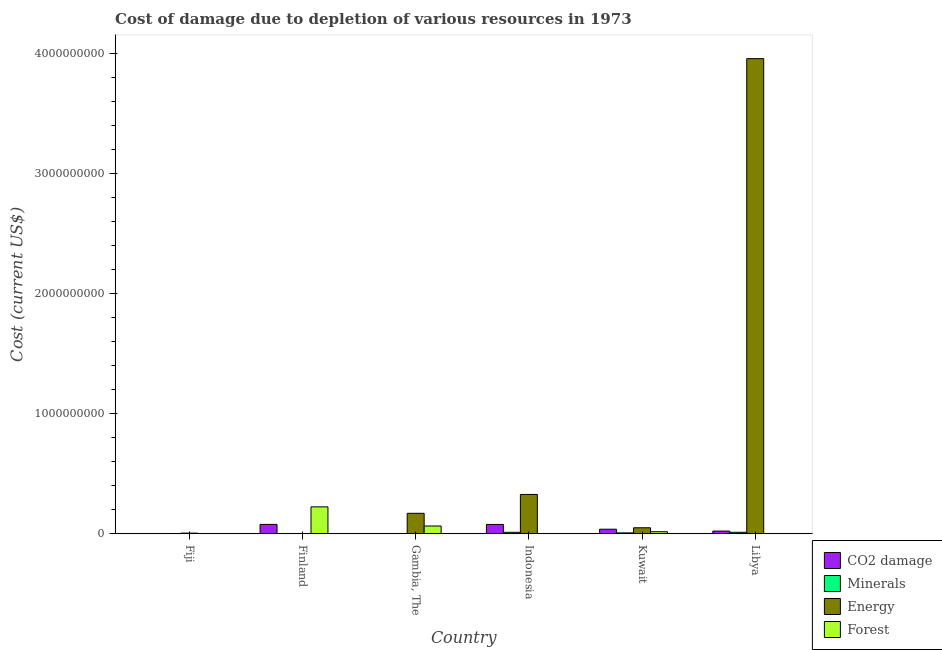Are the number of bars on each tick of the X-axis equal?
Keep it short and to the point. Yes. How many bars are there on the 1st tick from the left?
Your answer should be very brief. 4. How many bars are there on the 5th tick from the right?
Keep it short and to the point. 4. What is the label of the 6th group of bars from the left?
Make the answer very short. Libya. What is the cost of damage due to depletion of coal in Finland?
Ensure brevity in your answer.  7.89e+07. Across all countries, what is the maximum cost of damage due to depletion of coal?
Offer a terse response. 7.89e+07. Across all countries, what is the minimum cost of damage due to depletion of forests?
Make the answer very short. 4.73e+05. In which country was the cost of damage due to depletion of coal maximum?
Make the answer very short. Finland. In which country was the cost of damage due to depletion of forests minimum?
Your response must be concise. Libya. What is the total cost of damage due to depletion of energy in the graph?
Offer a very short reply. 4.52e+09. What is the difference between the cost of damage due to depletion of energy in Gambia, The and that in Libya?
Provide a short and direct response. -3.79e+09. What is the difference between the cost of damage due to depletion of minerals in Gambia, The and the cost of damage due to depletion of forests in Kuwait?
Your response must be concise. -1.75e+07. What is the average cost of damage due to depletion of energy per country?
Your response must be concise. 7.53e+08. What is the difference between the cost of damage due to depletion of forests and cost of damage due to depletion of minerals in Fiji?
Give a very brief answer. -1.21e+06. In how many countries, is the cost of damage due to depletion of energy greater than 1800000000 US$?
Give a very brief answer. 1. What is the ratio of the cost of damage due to depletion of minerals in Finland to that in Libya?
Your answer should be very brief. 0. Is the difference between the cost of damage due to depletion of forests in Fiji and Indonesia greater than the difference between the cost of damage due to depletion of minerals in Fiji and Indonesia?
Keep it short and to the point. Yes. What is the difference between the highest and the second highest cost of damage due to depletion of energy?
Offer a very short reply. 3.63e+09. What is the difference between the highest and the lowest cost of damage due to depletion of minerals?
Your answer should be compact. 1.30e+07. In how many countries, is the cost of damage due to depletion of energy greater than the average cost of damage due to depletion of energy taken over all countries?
Your response must be concise. 1. Is it the case that in every country, the sum of the cost of damage due to depletion of forests and cost of damage due to depletion of coal is greater than the sum of cost of damage due to depletion of energy and cost of damage due to depletion of minerals?
Ensure brevity in your answer.  No. What does the 4th bar from the left in Finland represents?
Make the answer very short. Forest. What does the 2nd bar from the right in Finland represents?
Keep it short and to the point. Energy. Are all the bars in the graph horizontal?
Your answer should be compact. No. How many countries are there in the graph?
Make the answer very short. 6. What is the difference between two consecutive major ticks on the Y-axis?
Offer a very short reply. 1.00e+09. Are the values on the major ticks of Y-axis written in scientific E-notation?
Offer a very short reply. No. Does the graph contain any zero values?
Your answer should be compact. No. Where does the legend appear in the graph?
Provide a short and direct response. Bottom right. What is the title of the graph?
Offer a very short reply. Cost of damage due to depletion of various resources in 1973 . What is the label or title of the Y-axis?
Make the answer very short. Cost (current US$). What is the Cost (current US$) in CO2 damage in Fiji?
Ensure brevity in your answer.  1.01e+06. What is the Cost (current US$) of Minerals in Fiji?
Offer a terse response. 3.11e+06. What is the Cost (current US$) of Energy in Fiji?
Your response must be concise. 6.23e+06. What is the Cost (current US$) of Forest in Fiji?
Make the answer very short. 1.90e+06. What is the Cost (current US$) of CO2 damage in Finland?
Your response must be concise. 7.89e+07. What is the Cost (current US$) in Minerals in Finland?
Make the answer very short. 5.65e+04. What is the Cost (current US$) in Energy in Finland?
Your answer should be compact. 1.24e+06. What is the Cost (current US$) in Forest in Finland?
Make the answer very short. 2.25e+08. What is the Cost (current US$) in CO2 damage in Gambia, The?
Give a very brief answer. 9.96e+04. What is the Cost (current US$) in Minerals in Gambia, The?
Provide a short and direct response. 1.93e+05. What is the Cost (current US$) of Energy in Gambia, The?
Give a very brief answer. 1.71e+08. What is the Cost (current US$) of Forest in Gambia, The?
Your answer should be compact. 6.54e+07. What is the Cost (current US$) in CO2 damage in Indonesia?
Your answer should be compact. 7.85e+07. What is the Cost (current US$) of Minerals in Indonesia?
Your answer should be compact. 1.30e+07. What is the Cost (current US$) of Energy in Indonesia?
Your answer should be very brief. 3.29e+08. What is the Cost (current US$) in Forest in Indonesia?
Offer a terse response. 9.01e+05. What is the Cost (current US$) in CO2 damage in Kuwait?
Provide a short and direct response. 3.87e+07. What is the Cost (current US$) of Minerals in Kuwait?
Provide a short and direct response. 8.13e+06. What is the Cost (current US$) of Energy in Kuwait?
Your answer should be very brief. 5.08e+07. What is the Cost (current US$) of Forest in Kuwait?
Offer a terse response. 1.77e+07. What is the Cost (current US$) in CO2 damage in Libya?
Your response must be concise. 2.33e+07. What is the Cost (current US$) of Minerals in Libya?
Keep it short and to the point. 1.31e+07. What is the Cost (current US$) in Energy in Libya?
Offer a very short reply. 3.96e+09. What is the Cost (current US$) in Forest in Libya?
Provide a short and direct response. 4.73e+05. Across all countries, what is the maximum Cost (current US$) in CO2 damage?
Make the answer very short. 7.89e+07. Across all countries, what is the maximum Cost (current US$) of Minerals?
Your response must be concise. 1.31e+07. Across all countries, what is the maximum Cost (current US$) in Energy?
Make the answer very short. 3.96e+09. Across all countries, what is the maximum Cost (current US$) in Forest?
Ensure brevity in your answer.  2.25e+08. Across all countries, what is the minimum Cost (current US$) of CO2 damage?
Give a very brief answer. 9.96e+04. Across all countries, what is the minimum Cost (current US$) of Minerals?
Keep it short and to the point. 5.65e+04. Across all countries, what is the minimum Cost (current US$) in Energy?
Make the answer very short. 1.24e+06. Across all countries, what is the minimum Cost (current US$) in Forest?
Your response must be concise. 4.73e+05. What is the total Cost (current US$) in CO2 damage in the graph?
Keep it short and to the point. 2.21e+08. What is the total Cost (current US$) in Minerals in the graph?
Ensure brevity in your answer.  3.76e+07. What is the total Cost (current US$) in Energy in the graph?
Provide a short and direct response. 4.52e+09. What is the total Cost (current US$) in Forest in the graph?
Your answer should be compact. 3.12e+08. What is the difference between the Cost (current US$) of CO2 damage in Fiji and that in Finland?
Make the answer very short. -7.79e+07. What is the difference between the Cost (current US$) of Minerals in Fiji and that in Finland?
Ensure brevity in your answer.  3.05e+06. What is the difference between the Cost (current US$) of Energy in Fiji and that in Finland?
Make the answer very short. 4.99e+06. What is the difference between the Cost (current US$) of Forest in Fiji and that in Finland?
Provide a succinct answer. -2.23e+08. What is the difference between the Cost (current US$) in CO2 damage in Fiji and that in Gambia, The?
Your answer should be very brief. 9.08e+05. What is the difference between the Cost (current US$) in Minerals in Fiji and that in Gambia, The?
Keep it short and to the point. 2.92e+06. What is the difference between the Cost (current US$) in Energy in Fiji and that in Gambia, The?
Give a very brief answer. -1.65e+08. What is the difference between the Cost (current US$) in Forest in Fiji and that in Gambia, The?
Offer a very short reply. -6.35e+07. What is the difference between the Cost (current US$) of CO2 damage in Fiji and that in Indonesia?
Ensure brevity in your answer.  -7.75e+07. What is the difference between the Cost (current US$) of Minerals in Fiji and that in Indonesia?
Provide a succinct answer. -9.91e+06. What is the difference between the Cost (current US$) of Energy in Fiji and that in Indonesia?
Your response must be concise. -3.22e+08. What is the difference between the Cost (current US$) of Forest in Fiji and that in Indonesia?
Keep it short and to the point. 1.00e+06. What is the difference between the Cost (current US$) in CO2 damage in Fiji and that in Kuwait?
Your answer should be very brief. -3.77e+07. What is the difference between the Cost (current US$) in Minerals in Fiji and that in Kuwait?
Provide a short and direct response. -5.02e+06. What is the difference between the Cost (current US$) of Energy in Fiji and that in Kuwait?
Ensure brevity in your answer.  -4.46e+07. What is the difference between the Cost (current US$) of Forest in Fiji and that in Kuwait?
Your response must be concise. -1.58e+07. What is the difference between the Cost (current US$) in CO2 damage in Fiji and that in Libya?
Your answer should be compact. -2.23e+07. What is the difference between the Cost (current US$) in Minerals in Fiji and that in Libya?
Offer a terse response. -9.97e+06. What is the difference between the Cost (current US$) in Energy in Fiji and that in Libya?
Your answer should be very brief. -3.96e+09. What is the difference between the Cost (current US$) in Forest in Fiji and that in Libya?
Your answer should be compact. 1.43e+06. What is the difference between the Cost (current US$) of CO2 damage in Finland and that in Gambia, The?
Give a very brief answer. 7.88e+07. What is the difference between the Cost (current US$) in Minerals in Finland and that in Gambia, The?
Your answer should be very brief. -1.36e+05. What is the difference between the Cost (current US$) of Energy in Finland and that in Gambia, The?
Ensure brevity in your answer.  -1.70e+08. What is the difference between the Cost (current US$) in Forest in Finland and that in Gambia, The?
Provide a succinct answer. 1.60e+08. What is the difference between the Cost (current US$) of CO2 damage in Finland and that in Indonesia?
Offer a terse response. 4.04e+05. What is the difference between the Cost (current US$) of Minerals in Finland and that in Indonesia?
Your response must be concise. -1.30e+07. What is the difference between the Cost (current US$) of Energy in Finland and that in Indonesia?
Give a very brief answer. -3.27e+08. What is the difference between the Cost (current US$) of Forest in Finland and that in Indonesia?
Your answer should be compact. 2.24e+08. What is the difference between the Cost (current US$) of CO2 damage in Finland and that in Kuwait?
Ensure brevity in your answer.  4.02e+07. What is the difference between the Cost (current US$) in Minerals in Finland and that in Kuwait?
Your answer should be compact. -8.07e+06. What is the difference between the Cost (current US$) in Energy in Finland and that in Kuwait?
Give a very brief answer. -4.96e+07. What is the difference between the Cost (current US$) of Forest in Finland and that in Kuwait?
Make the answer very short. 2.07e+08. What is the difference between the Cost (current US$) of CO2 damage in Finland and that in Libya?
Give a very brief answer. 5.56e+07. What is the difference between the Cost (current US$) in Minerals in Finland and that in Libya?
Give a very brief answer. -1.30e+07. What is the difference between the Cost (current US$) in Energy in Finland and that in Libya?
Give a very brief answer. -3.96e+09. What is the difference between the Cost (current US$) in Forest in Finland and that in Libya?
Your response must be concise. 2.25e+08. What is the difference between the Cost (current US$) in CO2 damage in Gambia, The and that in Indonesia?
Your answer should be compact. -7.84e+07. What is the difference between the Cost (current US$) of Minerals in Gambia, The and that in Indonesia?
Provide a short and direct response. -1.28e+07. What is the difference between the Cost (current US$) in Energy in Gambia, The and that in Indonesia?
Your answer should be very brief. -1.57e+08. What is the difference between the Cost (current US$) in Forest in Gambia, The and that in Indonesia?
Keep it short and to the point. 6.45e+07. What is the difference between the Cost (current US$) in CO2 damage in Gambia, The and that in Kuwait?
Provide a succinct answer. -3.86e+07. What is the difference between the Cost (current US$) in Minerals in Gambia, The and that in Kuwait?
Your answer should be very brief. -7.94e+06. What is the difference between the Cost (current US$) in Energy in Gambia, The and that in Kuwait?
Offer a terse response. 1.21e+08. What is the difference between the Cost (current US$) of Forest in Gambia, The and that in Kuwait?
Keep it short and to the point. 4.77e+07. What is the difference between the Cost (current US$) of CO2 damage in Gambia, The and that in Libya?
Provide a short and direct response. -2.32e+07. What is the difference between the Cost (current US$) in Minerals in Gambia, The and that in Libya?
Your answer should be compact. -1.29e+07. What is the difference between the Cost (current US$) of Energy in Gambia, The and that in Libya?
Give a very brief answer. -3.79e+09. What is the difference between the Cost (current US$) in Forest in Gambia, The and that in Libya?
Keep it short and to the point. 6.50e+07. What is the difference between the Cost (current US$) of CO2 damage in Indonesia and that in Kuwait?
Your answer should be very brief. 3.98e+07. What is the difference between the Cost (current US$) in Minerals in Indonesia and that in Kuwait?
Offer a very short reply. 4.89e+06. What is the difference between the Cost (current US$) of Energy in Indonesia and that in Kuwait?
Your answer should be compact. 2.78e+08. What is the difference between the Cost (current US$) in Forest in Indonesia and that in Kuwait?
Your answer should be very brief. -1.68e+07. What is the difference between the Cost (current US$) of CO2 damage in Indonesia and that in Libya?
Keep it short and to the point. 5.52e+07. What is the difference between the Cost (current US$) of Minerals in Indonesia and that in Libya?
Your answer should be compact. -6.05e+04. What is the difference between the Cost (current US$) of Energy in Indonesia and that in Libya?
Keep it short and to the point. -3.63e+09. What is the difference between the Cost (current US$) of Forest in Indonesia and that in Libya?
Offer a terse response. 4.28e+05. What is the difference between the Cost (current US$) in CO2 damage in Kuwait and that in Libya?
Keep it short and to the point. 1.54e+07. What is the difference between the Cost (current US$) in Minerals in Kuwait and that in Libya?
Your response must be concise. -4.95e+06. What is the difference between the Cost (current US$) in Energy in Kuwait and that in Libya?
Your response must be concise. -3.91e+09. What is the difference between the Cost (current US$) in Forest in Kuwait and that in Libya?
Your answer should be compact. 1.73e+07. What is the difference between the Cost (current US$) in CO2 damage in Fiji and the Cost (current US$) in Minerals in Finland?
Offer a very short reply. 9.51e+05. What is the difference between the Cost (current US$) in CO2 damage in Fiji and the Cost (current US$) in Energy in Finland?
Make the answer very short. -2.37e+05. What is the difference between the Cost (current US$) in CO2 damage in Fiji and the Cost (current US$) in Forest in Finland?
Provide a short and direct response. -2.24e+08. What is the difference between the Cost (current US$) of Minerals in Fiji and the Cost (current US$) of Energy in Finland?
Keep it short and to the point. 1.87e+06. What is the difference between the Cost (current US$) of Minerals in Fiji and the Cost (current US$) of Forest in Finland?
Keep it short and to the point. -2.22e+08. What is the difference between the Cost (current US$) in Energy in Fiji and the Cost (current US$) in Forest in Finland?
Ensure brevity in your answer.  -2.19e+08. What is the difference between the Cost (current US$) of CO2 damage in Fiji and the Cost (current US$) of Minerals in Gambia, The?
Give a very brief answer. 8.15e+05. What is the difference between the Cost (current US$) in CO2 damage in Fiji and the Cost (current US$) in Energy in Gambia, The?
Offer a terse response. -1.70e+08. What is the difference between the Cost (current US$) in CO2 damage in Fiji and the Cost (current US$) in Forest in Gambia, The?
Offer a very short reply. -6.44e+07. What is the difference between the Cost (current US$) of Minerals in Fiji and the Cost (current US$) of Energy in Gambia, The?
Your answer should be compact. -1.68e+08. What is the difference between the Cost (current US$) of Minerals in Fiji and the Cost (current US$) of Forest in Gambia, The?
Provide a succinct answer. -6.23e+07. What is the difference between the Cost (current US$) in Energy in Fiji and the Cost (current US$) in Forest in Gambia, The?
Give a very brief answer. -5.92e+07. What is the difference between the Cost (current US$) of CO2 damage in Fiji and the Cost (current US$) of Minerals in Indonesia?
Provide a short and direct response. -1.20e+07. What is the difference between the Cost (current US$) of CO2 damage in Fiji and the Cost (current US$) of Energy in Indonesia?
Keep it short and to the point. -3.28e+08. What is the difference between the Cost (current US$) of CO2 damage in Fiji and the Cost (current US$) of Forest in Indonesia?
Your response must be concise. 1.07e+05. What is the difference between the Cost (current US$) of Minerals in Fiji and the Cost (current US$) of Energy in Indonesia?
Provide a succinct answer. -3.26e+08. What is the difference between the Cost (current US$) in Minerals in Fiji and the Cost (current US$) in Forest in Indonesia?
Provide a short and direct response. 2.21e+06. What is the difference between the Cost (current US$) of Energy in Fiji and the Cost (current US$) of Forest in Indonesia?
Offer a very short reply. 5.33e+06. What is the difference between the Cost (current US$) in CO2 damage in Fiji and the Cost (current US$) in Minerals in Kuwait?
Ensure brevity in your answer.  -7.12e+06. What is the difference between the Cost (current US$) of CO2 damage in Fiji and the Cost (current US$) of Energy in Kuwait?
Provide a short and direct response. -4.98e+07. What is the difference between the Cost (current US$) of CO2 damage in Fiji and the Cost (current US$) of Forest in Kuwait?
Make the answer very short. -1.67e+07. What is the difference between the Cost (current US$) in Minerals in Fiji and the Cost (current US$) in Energy in Kuwait?
Offer a terse response. -4.77e+07. What is the difference between the Cost (current US$) in Minerals in Fiji and the Cost (current US$) in Forest in Kuwait?
Keep it short and to the point. -1.46e+07. What is the difference between the Cost (current US$) in Energy in Fiji and the Cost (current US$) in Forest in Kuwait?
Ensure brevity in your answer.  -1.15e+07. What is the difference between the Cost (current US$) of CO2 damage in Fiji and the Cost (current US$) of Minerals in Libya?
Keep it short and to the point. -1.21e+07. What is the difference between the Cost (current US$) in CO2 damage in Fiji and the Cost (current US$) in Energy in Libya?
Provide a short and direct response. -3.96e+09. What is the difference between the Cost (current US$) of CO2 damage in Fiji and the Cost (current US$) of Forest in Libya?
Your answer should be compact. 5.35e+05. What is the difference between the Cost (current US$) of Minerals in Fiji and the Cost (current US$) of Energy in Libya?
Offer a terse response. -3.96e+09. What is the difference between the Cost (current US$) of Minerals in Fiji and the Cost (current US$) of Forest in Libya?
Your response must be concise. 2.64e+06. What is the difference between the Cost (current US$) in Energy in Fiji and the Cost (current US$) in Forest in Libya?
Your answer should be very brief. 5.76e+06. What is the difference between the Cost (current US$) in CO2 damage in Finland and the Cost (current US$) in Minerals in Gambia, The?
Your answer should be very brief. 7.87e+07. What is the difference between the Cost (current US$) of CO2 damage in Finland and the Cost (current US$) of Energy in Gambia, The?
Keep it short and to the point. -9.24e+07. What is the difference between the Cost (current US$) in CO2 damage in Finland and the Cost (current US$) in Forest in Gambia, The?
Make the answer very short. 1.35e+07. What is the difference between the Cost (current US$) of Minerals in Finland and the Cost (current US$) of Energy in Gambia, The?
Provide a succinct answer. -1.71e+08. What is the difference between the Cost (current US$) of Minerals in Finland and the Cost (current US$) of Forest in Gambia, The?
Your answer should be very brief. -6.54e+07. What is the difference between the Cost (current US$) of Energy in Finland and the Cost (current US$) of Forest in Gambia, The?
Offer a very short reply. -6.42e+07. What is the difference between the Cost (current US$) in CO2 damage in Finland and the Cost (current US$) in Minerals in Indonesia?
Provide a succinct answer. 6.59e+07. What is the difference between the Cost (current US$) of CO2 damage in Finland and the Cost (current US$) of Energy in Indonesia?
Keep it short and to the point. -2.50e+08. What is the difference between the Cost (current US$) in CO2 damage in Finland and the Cost (current US$) in Forest in Indonesia?
Ensure brevity in your answer.  7.80e+07. What is the difference between the Cost (current US$) of Minerals in Finland and the Cost (current US$) of Energy in Indonesia?
Your answer should be very brief. -3.29e+08. What is the difference between the Cost (current US$) of Minerals in Finland and the Cost (current US$) of Forest in Indonesia?
Your response must be concise. -8.44e+05. What is the difference between the Cost (current US$) of Energy in Finland and the Cost (current US$) of Forest in Indonesia?
Ensure brevity in your answer.  3.44e+05. What is the difference between the Cost (current US$) in CO2 damage in Finland and the Cost (current US$) in Minerals in Kuwait?
Your answer should be very brief. 7.08e+07. What is the difference between the Cost (current US$) of CO2 damage in Finland and the Cost (current US$) of Energy in Kuwait?
Your answer should be very brief. 2.81e+07. What is the difference between the Cost (current US$) of CO2 damage in Finland and the Cost (current US$) of Forest in Kuwait?
Keep it short and to the point. 6.12e+07. What is the difference between the Cost (current US$) of Minerals in Finland and the Cost (current US$) of Energy in Kuwait?
Ensure brevity in your answer.  -5.07e+07. What is the difference between the Cost (current US$) of Minerals in Finland and the Cost (current US$) of Forest in Kuwait?
Offer a very short reply. -1.77e+07. What is the difference between the Cost (current US$) in Energy in Finland and the Cost (current US$) in Forest in Kuwait?
Make the answer very short. -1.65e+07. What is the difference between the Cost (current US$) of CO2 damage in Finland and the Cost (current US$) of Minerals in Libya?
Provide a succinct answer. 6.58e+07. What is the difference between the Cost (current US$) in CO2 damage in Finland and the Cost (current US$) in Energy in Libya?
Keep it short and to the point. -3.88e+09. What is the difference between the Cost (current US$) in CO2 damage in Finland and the Cost (current US$) in Forest in Libya?
Provide a short and direct response. 7.84e+07. What is the difference between the Cost (current US$) of Minerals in Finland and the Cost (current US$) of Energy in Libya?
Offer a terse response. -3.96e+09. What is the difference between the Cost (current US$) of Minerals in Finland and the Cost (current US$) of Forest in Libya?
Your answer should be compact. -4.16e+05. What is the difference between the Cost (current US$) in Energy in Finland and the Cost (current US$) in Forest in Libya?
Keep it short and to the point. 7.72e+05. What is the difference between the Cost (current US$) in CO2 damage in Gambia, The and the Cost (current US$) in Minerals in Indonesia?
Your answer should be compact. -1.29e+07. What is the difference between the Cost (current US$) in CO2 damage in Gambia, The and the Cost (current US$) in Energy in Indonesia?
Make the answer very short. -3.29e+08. What is the difference between the Cost (current US$) in CO2 damage in Gambia, The and the Cost (current US$) in Forest in Indonesia?
Your response must be concise. -8.01e+05. What is the difference between the Cost (current US$) in Minerals in Gambia, The and the Cost (current US$) in Energy in Indonesia?
Your answer should be very brief. -3.28e+08. What is the difference between the Cost (current US$) of Minerals in Gambia, The and the Cost (current US$) of Forest in Indonesia?
Your answer should be compact. -7.08e+05. What is the difference between the Cost (current US$) in Energy in Gambia, The and the Cost (current US$) in Forest in Indonesia?
Ensure brevity in your answer.  1.70e+08. What is the difference between the Cost (current US$) in CO2 damage in Gambia, The and the Cost (current US$) in Minerals in Kuwait?
Offer a very short reply. -8.03e+06. What is the difference between the Cost (current US$) of CO2 damage in Gambia, The and the Cost (current US$) of Energy in Kuwait?
Offer a terse response. -5.07e+07. What is the difference between the Cost (current US$) in CO2 damage in Gambia, The and the Cost (current US$) in Forest in Kuwait?
Your response must be concise. -1.76e+07. What is the difference between the Cost (current US$) of Minerals in Gambia, The and the Cost (current US$) of Energy in Kuwait?
Provide a succinct answer. -5.06e+07. What is the difference between the Cost (current US$) in Minerals in Gambia, The and the Cost (current US$) in Forest in Kuwait?
Make the answer very short. -1.75e+07. What is the difference between the Cost (current US$) in Energy in Gambia, The and the Cost (current US$) in Forest in Kuwait?
Your answer should be compact. 1.54e+08. What is the difference between the Cost (current US$) of CO2 damage in Gambia, The and the Cost (current US$) of Minerals in Libya?
Keep it short and to the point. -1.30e+07. What is the difference between the Cost (current US$) in CO2 damage in Gambia, The and the Cost (current US$) in Energy in Libya?
Your answer should be compact. -3.96e+09. What is the difference between the Cost (current US$) in CO2 damage in Gambia, The and the Cost (current US$) in Forest in Libya?
Provide a short and direct response. -3.73e+05. What is the difference between the Cost (current US$) in Minerals in Gambia, The and the Cost (current US$) in Energy in Libya?
Offer a terse response. -3.96e+09. What is the difference between the Cost (current US$) of Minerals in Gambia, The and the Cost (current US$) of Forest in Libya?
Offer a terse response. -2.80e+05. What is the difference between the Cost (current US$) in Energy in Gambia, The and the Cost (current US$) in Forest in Libya?
Give a very brief answer. 1.71e+08. What is the difference between the Cost (current US$) of CO2 damage in Indonesia and the Cost (current US$) of Minerals in Kuwait?
Keep it short and to the point. 7.04e+07. What is the difference between the Cost (current US$) of CO2 damage in Indonesia and the Cost (current US$) of Energy in Kuwait?
Your response must be concise. 2.77e+07. What is the difference between the Cost (current US$) in CO2 damage in Indonesia and the Cost (current US$) in Forest in Kuwait?
Offer a very short reply. 6.08e+07. What is the difference between the Cost (current US$) in Minerals in Indonesia and the Cost (current US$) in Energy in Kuwait?
Offer a very short reply. -3.78e+07. What is the difference between the Cost (current US$) of Minerals in Indonesia and the Cost (current US$) of Forest in Kuwait?
Give a very brief answer. -4.72e+06. What is the difference between the Cost (current US$) of Energy in Indonesia and the Cost (current US$) of Forest in Kuwait?
Your response must be concise. 3.11e+08. What is the difference between the Cost (current US$) in CO2 damage in Indonesia and the Cost (current US$) in Minerals in Libya?
Your response must be concise. 6.54e+07. What is the difference between the Cost (current US$) of CO2 damage in Indonesia and the Cost (current US$) of Energy in Libya?
Keep it short and to the point. -3.88e+09. What is the difference between the Cost (current US$) of CO2 damage in Indonesia and the Cost (current US$) of Forest in Libya?
Offer a terse response. 7.80e+07. What is the difference between the Cost (current US$) of Minerals in Indonesia and the Cost (current US$) of Energy in Libya?
Give a very brief answer. -3.95e+09. What is the difference between the Cost (current US$) of Minerals in Indonesia and the Cost (current US$) of Forest in Libya?
Ensure brevity in your answer.  1.25e+07. What is the difference between the Cost (current US$) in Energy in Indonesia and the Cost (current US$) in Forest in Libya?
Offer a very short reply. 3.28e+08. What is the difference between the Cost (current US$) of CO2 damage in Kuwait and the Cost (current US$) of Minerals in Libya?
Make the answer very short. 2.57e+07. What is the difference between the Cost (current US$) in CO2 damage in Kuwait and the Cost (current US$) in Energy in Libya?
Offer a very short reply. -3.92e+09. What is the difference between the Cost (current US$) of CO2 damage in Kuwait and the Cost (current US$) of Forest in Libya?
Make the answer very short. 3.83e+07. What is the difference between the Cost (current US$) in Minerals in Kuwait and the Cost (current US$) in Energy in Libya?
Give a very brief answer. -3.95e+09. What is the difference between the Cost (current US$) of Minerals in Kuwait and the Cost (current US$) of Forest in Libya?
Your response must be concise. 7.65e+06. What is the difference between the Cost (current US$) in Energy in Kuwait and the Cost (current US$) in Forest in Libya?
Your response must be concise. 5.03e+07. What is the average Cost (current US$) in CO2 damage per country?
Provide a succinct answer. 3.68e+07. What is the average Cost (current US$) in Minerals per country?
Your response must be concise. 6.26e+06. What is the average Cost (current US$) of Energy per country?
Offer a terse response. 7.53e+08. What is the average Cost (current US$) in Forest per country?
Offer a terse response. 5.19e+07. What is the difference between the Cost (current US$) in CO2 damage and Cost (current US$) in Minerals in Fiji?
Make the answer very short. -2.10e+06. What is the difference between the Cost (current US$) of CO2 damage and Cost (current US$) of Energy in Fiji?
Your answer should be very brief. -5.22e+06. What is the difference between the Cost (current US$) of CO2 damage and Cost (current US$) of Forest in Fiji?
Your answer should be very brief. -8.93e+05. What is the difference between the Cost (current US$) of Minerals and Cost (current US$) of Energy in Fiji?
Offer a terse response. -3.12e+06. What is the difference between the Cost (current US$) of Minerals and Cost (current US$) of Forest in Fiji?
Keep it short and to the point. 1.21e+06. What is the difference between the Cost (current US$) of Energy and Cost (current US$) of Forest in Fiji?
Make the answer very short. 4.33e+06. What is the difference between the Cost (current US$) of CO2 damage and Cost (current US$) of Minerals in Finland?
Provide a short and direct response. 7.89e+07. What is the difference between the Cost (current US$) in CO2 damage and Cost (current US$) in Energy in Finland?
Your answer should be compact. 7.77e+07. What is the difference between the Cost (current US$) in CO2 damage and Cost (current US$) in Forest in Finland?
Your answer should be very brief. -1.46e+08. What is the difference between the Cost (current US$) in Minerals and Cost (current US$) in Energy in Finland?
Your answer should be very brief. -1.19e+06. What is the difference between the Cost (current US$) in Minerals and Cost (current US$) in Forest in Finland?
Ensure brevity in your answer.  -2.25e+08. What is the difference between the Cost (current US$) in Energy and Cost (current US$) in Forest in Finland?
Your answer should be compact. -2.24e+08. What is the difference between the Cost (current US$) of CO2 damage and Cost (current US$) of Minerals in Gambia, The?
Give a very brief answer. -9.30e+04. What is the difference between the Cost (current US$) in CO2 damage and Cost (current US$) in Energy in Gambia, The?
Provide a short and direct response. -1.71e+08. What is the difference between the Cost (current US$) of CO2 damage and Cost (current US$) of Forest in Gambia, The?
Offer a terse response. -6.53e+07. What is the difference between the Cost (current US$) of Minerals and Cost (current US$) of Energy in Gambia, The?
Ensure brevity in your answer.  -1.71e+08. What is the difference between the Cost (current US$) of Minerals and Cost (current US$) of Forest in Gambia, The?
Make the answer very short. -6.53e+07. What is the difference between the Cost (current US$) of Energy and Cost (current US$) of Forest in Gambia, The?
Offer a very short reply. 1.06e+08. What is the difference between the Cost (current US$) in CO2 damage and Cost (current US$) in Minerals in Indonesia?
Offer a terse response. 6.55e+07. What is the difference between the Cost (current US$) in CO2 damage and Cost (current US$) in Energy in Indonesia?
Make the answer very short. -2.50e+08. What is the difference between the Cost (current US$) in CO2 damage and Cost (current US$) in Forest in Indonesia?
Offer a terse response. 7.76e+07. What is the difference between the Cost (current US$) of Minerals and Cost (current US$) of Energy in Indonesia?
Offer a terse response. -3.16e+08. What is the difference between the Cost (current US$) in Minerals and Cost (current US$) in Forest in Indonesia?
Your response must be concise. 1.21e+07. What is the difference between the Cost (current US$) of Energy and Cost (current US$) of Forest in Indonesia?
Offer a very short reply. 3.28e+08. What is the difference between the Cost (current US$) in CO2 damage and Cost (current US$) in Minerals in Kuwait?
Your response must be concise. 3.06e+07. What is the difference between the Cost (current US$) in CO2 damage and Cost (current US$) in Energy in Kuwait?
Make the answer very short. -1.21e+07. What is the difference between the Cost (current US$) in CO2 damage and Cost (current US$) in Forest in Kuwait?
Keep it short and to the point. 2.10e+07. What is the difference between the Cost (current US$) of Minerals and Cost (current US$) of Energy in Kuwait?
Give a very brief answer. -4.27e+07. What is the difference between the Cost (current US$) in Minerals and Cost (current US$) in Forest in Kuwait?
Your answer should be very brief. -9.61e+06. What is the difference between the Cost (current US$) of Energy and Cost (current US$) of Forest in Kuwait?
Offer a very short reply. 3.31e+07. What is the difference between the Cost (current US$) in CO2 damage and Cost (current US$) in Minerals in Libya?
Keep it short and to the point. 1.02e+07. What is the difference between the Cost (current US$) in CO2 damage and Cost (current US$) in Energy in Libya?
Your answer should be compact. -3.94e+09. What is the difference between the Cost (current US$) in CO2 damage and Cost (current US$) in Forest in Libya?
Keep it short and to the point. 2.28e+07. What is the difference between the Cost (current US$) of Minerals and Cost (current US$) of Energy in Libya?
Keep it short and to the point. -3.95e+09. What is the difference between the Cost (current US$) in Minerals and Cost (current US$) in Forest in Libya?
Your answer should be compact. 1.26e+07. What is the difference between the Cost (current US$) of Energy and Cost (current US$) of Forest in Libya?
Keep it short and to the point. 3.96e+09. What is the ratio of the Cost (current US$) in CO2 damage in Fiji to that in Finland?
Your answer should be compact. 0.01. What is the ratio of the Cost (current US$) of Minerals in Fiji to that in Finland?
Offer a terse response. 55.09. What is the ratio of the Cost (current US$) of Energy in Fiji to that in Finland?
Give a very brief answer. 5.01. What is the ratio of the Cost (current US$) of Forest in Fiji to that in Finland?
Provide a short and direct response. 0.01. What is the ratio of the Cost (current US$) in CO2 damage in Fiji to that in Gambia, The?
Provide a succinct answer. 10.12. What is the ratio of the Cost (current US$) in Minerals in Fiji to that in Gambia, The?
Keep it short and to the point. 16.15. What is the ratio of the Cost (current US$) of Energy in Fiji to that in Gambia, The?
Offer a terse response. 0.04. What is the ratio of the Cost (current US$) in Forest in Fiji to that in Gambia, The?
Ensure brevity in your answer.  0.03. What is the ratio of the Cost (current US$) in CO2 damage in Fiji to that in Indonesia?
Offer a very short reply. 0.01. What is the ratio of the Cost (current US$) of Minerals in Fiji to that in Indonesia?
Offer a terse response. 0.24. What is the ratio of the Cost (current US$) of Energy in Fiji to that in Indonesia?
Make the answer very short. 0.02. What is the ratio of the Cost (current US$) in Forest in Fiji to that in Indonesia?
Keep it short and to the point. 2.11. What is the ratio of the Cost (current US$) in CO2 damage in Fiji to that in Kuwait?
Keep it short and to the point. 0.03. What is the ratio of the Cost (current US$) in Minerals in Fiji to that in Kuwait?
Give a very brief answer. 0.38. What is the ratio of the Cost (current US$) in Energy in Fiji to that in Kuwait?
Your response must be concise. 0.12. What is the ratio of the Cost (current US$) of Forest in Fiji to that in Kuwait?
Provide a succinct answer. 0.11. What is the ratio of the Cost (current US$) of CO2 damage in Fiji to that in Libya?
Your response must be concise. 0.04. What is the ratio of the Cost (current US$) in Minerals in Fiji to that in Libya?
Offer a very short reply. 0.24. What is the ratio of the Cost (current US$) of Energy in Fiji to that in Libya?
Your answer should be compact. 0. What is the ratio of the Cost (current US$) in Forest in Fiji to that in Libya?
Offer a terse response. 4.02. What is the ratio of the Cost (current US$) of CO2 damage in Finland to that in Gambia, The?
Give a very brief answer. 792.24. What is the ratio of the Cost (current US$) in Minerals in Finland to that in Gambia, The?
Keep it short and to the point. 0.29. What is the ratio of the Cost (current US$) of Energy in Finland to that in Gambia, The?
Offer a terse response. 0.01. What is the ratio of the Cost (current US$) in Forest in Finland to that in Gambia, The?
Make the answer very short. 3.44. What is the ratio of the Cost (current US$) in Minerals in Finland to that in Indonesia?
Keep it short and to the point. 0. What is the ratio of the Cost (current US$) in Energy in Finland to that in Indonesia?
Give a very brief answer. 0. What is the ratio of the Cost (current US$) in Forest in Finland to that in Indonesia?
Keep it short and to the point. 249.95. What is the ratio of the Cost (current US$) in CO2 damage in Finland to that in Kuwait?
Offer a very short reply. 2.04. What is the ratio of the Cost (current US$) in Minerals in Finland to that in Kuwait?
Your response must be concise. 0.01. What is the ratio of the Cost (current US$) of Energy in Finland to that in Kuwait?
Keep it short and to the point. 0.02. What is the ratio of the Cost (current US$) of Forest in Finland to that in Kuwait?
Your answer should be very brief. 12.69. What is the ratio of the Cost (current US$) in CO2 damage in Finland to that in Libya?
Offer a very short reply. 3.39. What is the ratio of the Cost (current US$) in Minerals in Finland to that in Libya?
Provide a short and direct response. 0. What is the ratio of the Cost (current US$) of Forest in Finland to that in Libya?
Your answer should be very brief. 476.12. What is the ratio of the Cost (current US$) of CO2 damage in Gambia, The to that in Indonesia?
Ensure brevity in your answer.  0. What is the ratio of the Cost (current US$) in Minerals in Gambia, The to that in Indonesia?
Ensure brevity in your answer.  0.01. What is the ratio of the Cost (current US$) of Energy in Gambia, The to that in Indonesia?
Your answer should be compact. 0.52. What is the ratio of the Cost (current US$) in Forest in Gambia, The to that in Indonesia?
Your answer should be very brief. 72.65. What is the ratio of the Cost (current US$) of CO2 damage in Gambia, The to that in Kuwait?
Give a very brief answer. 0. What is the ratio of the Cost (current US$) in Minerals in Gambia, The to that in Kuwait?
Your response must be concise. 0.02. What is the ratio of the Cost (current US$) of Energy in Gambia, The to that in Kuwait?
Offer a very short reply. 3.37. What is the ratio of the Cost (current US$) of Forest in Gambia, The to that in Kuwait?
Your answer should be very brief. 3.69. What is the ratio of the Cost (current US$) of CO2 damage in Gambia, The to that in Libya?
Provide a succinct answer. 0. What is the ratio of the Cost (current US$) of Minerals in Gambia, The to that in Libya?
Provide a succinct answer. 0.01. What is the ratio of the Cost (current US$) in Energy in Gambia, The to that in Libya?
Give a very brief answer. 0.04. What is the ratio of the Cost (current US$) of Forest in Gambia, The to that in Libya?
Your answer should be very brief. 138.39. What is the ratio of the Cost (current US$) of CO2 damage in Indonesia to that in Kuwait?
Provide a succinct answer. 2.03. What is the ratio of the Cost (current US$) of Minerals in Indonesia to that in Kuwait?
Your answer should be very brief. 1.6. What is the ratio of the Cost (current US$) in Energy in Indonesia to that in Kuwait?
Provide a short and direct response. 6.47. What is the ratio of the Cost (current US$) of Forest in Indonesia to that in Kuwait?
Give a very brief answer. 0.05. What is the ratio of the Cost (current US$) in CO2 damage in Indonesia to that in Libya?
Your answer should be compact. 3.37. What is the ratio of the Cost (current US$) of Energy in Indonesia to that in Libya?
Your answer should be compact. 0.08. What is the ratio of the Cost (current US$) in Forest in Indonesia to that in Libya?
Your answer should be compact. 1.9. What is the ratio of the Cost (current US$) in CO2 damage in Kuwait to that in Libya?
Your answer should be very brief. 1.66. What is the ratio of the Cost (current US$) of Minerals in Kuwait to that in Libya?
Make the answer very short. 0.62. What is the ratio of the Cost (current US$) in Energy in Kuwait to that in Libya?
Your answer should be very brief. 0.01. What is the ratio of the Cost (current US$) of Forest in Kuwait to that in Libya?
Your answer should be very brief. 37.51. What is the difference between the highest and the second highest Cost (current US$) of CO2 damage?
Offer a very short reply. 4.04e+05. What is the difference between the highest and the second highest Cost (current US$) of Minerals?
Your answer should be very brief. 6.05e+04. What is the difference between the highest and the second highest Cost (current US$) of Energy?
Ensure brevity in your answer.  3.63e+09. What is the difference between the highest and the second highest Cost (current US$) of Forest?
Make the answer very short. 1.60e+08. What is the difference between the highest and the lowest Cost (current US$) of CO2 damage?
Offer a very short reply. 7.88e+07. What is the difference between the highest and the lowest Cost (current US$) in Minerals?
Make the answer very short. 1.30e+07. What is the difference between the highest and the lowest Cost (current US$) of Energy?
Your answer should be compact. 3.96e+09. What is the difference between the highest and the lowest Cost (current US$) of Forest?
Give a very brief answer. 2.25e+08. 